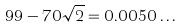Convert formula to latex. <formula><loc_0><loc_0><loc_500><loc_500>9 9 - 7 0 \sqrt { 2 } = 0 . 0 0 5 0 \dots</formula> 